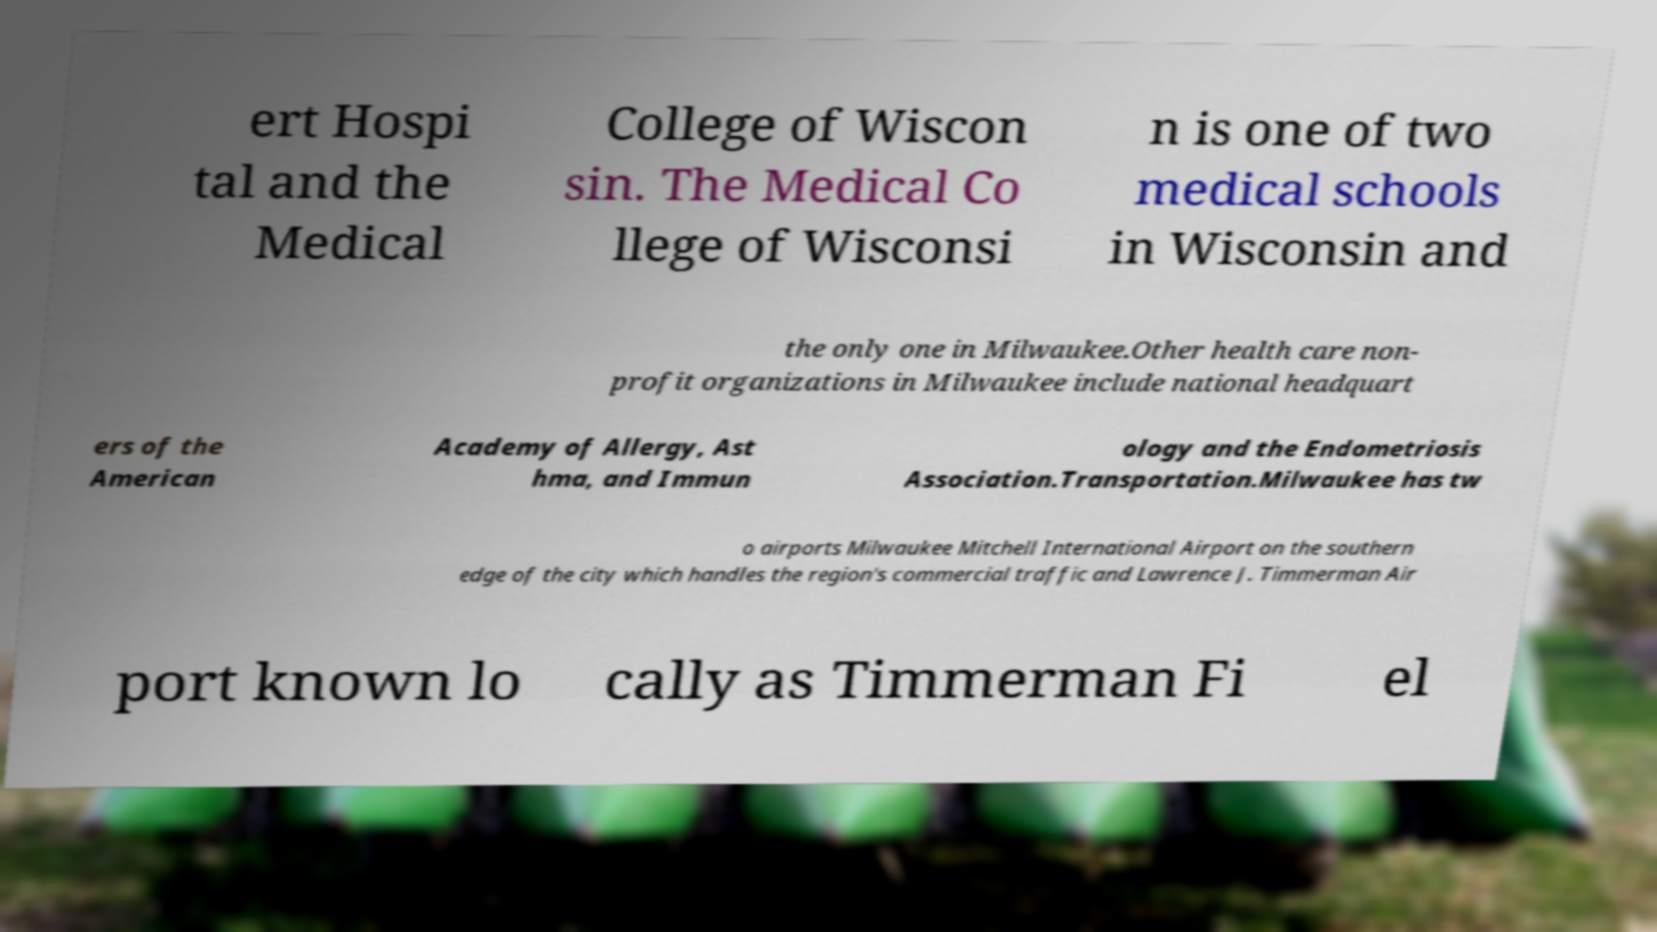Can you read and provide the text displayed in the image?This photo seems to have some interesting text. Can you extract and type it out for me? ert Hospi tal and the Medical College of Wiscon sin. The Medical Co llege of Wisconsi n is one of two medical schools in Wisconsin and the only one in Milwaukee.Other health care non- profit organizations in Milwaukee include national headquart ers of the American Academy of Allergy, Ast hma, and Immun ology and the Endometriosis Association.Transportation.Milwaukee has tw o airports Milwaukee Mitchell International Airport on the southern edge of the city which handles the region's commercial traffic and Lawrence J. Timmerman Air port known lo cally as Timmerman Fi el 